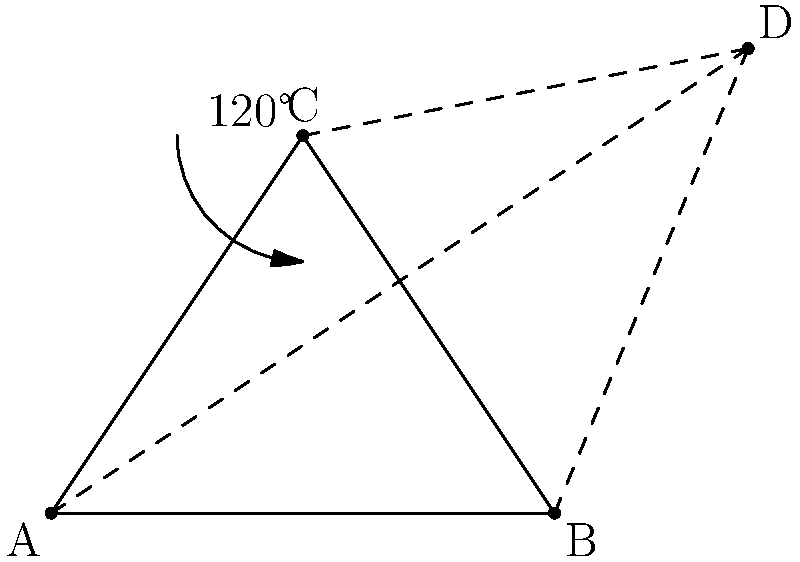In a Harlem Globetrotter's signature trick shot, the ball follows a path that can be modeled by geometric transformations. Given the triangle ABC representing the initial position and trajectory of the ball, what single transformation would move point A to point D, effectively creating the full path of the trick shot? To solve this problem, we need to analyze the geometric relationship between points A and D:

1. Observe that triangle ABC and triangle CBD share the same base BC.

2. The angle at C in both triangles is 120° (supplementary to the 60° angle in an equilateral triangle).

3. This configuration suggests that triangle CBD is a rotation of triangle ABC around point C.

4. The rotation angle is 120° clockwise, or equivalently, 240° counterclockwise.

5. Therefore, the transformation that moves point A to point D is a rotation of 240° counterclockwise around point C.

In group theory terms, this rotation belongs to the cyclic group C3 (order 3), which is a subgroup of the symmetry group of an equilateral triangle.
Answer: 240° counterclockwise rotation around point C 